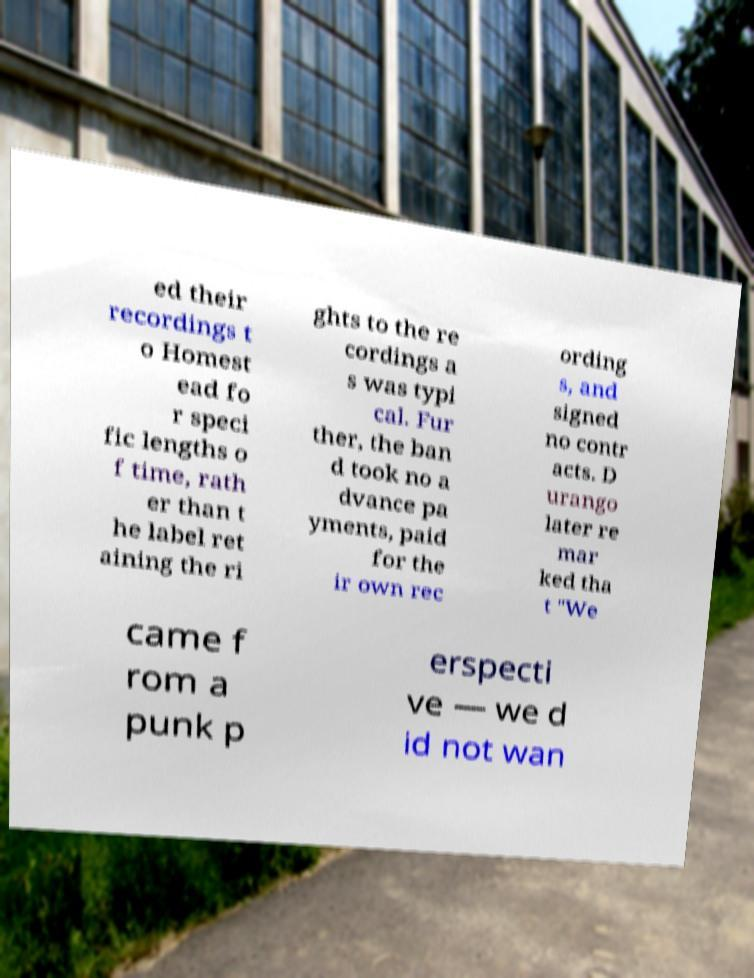Can you read and provide the text displayed in the image?This photo seems to have some interesting text. Can you extract and type it out for me? ed their recordings t o Homest ead fo r speci fic lengths o f time, rath er than t he label ret aining the ri ghts to the re cordings a s was typi cal. Fur ther, the ban d took no a dvance pa yments, paid for the ir own rec ording s, and signed no contr acts. D urango later re mar ked tha t "We came f rom a punk p erspecti ve — we d id not wan 